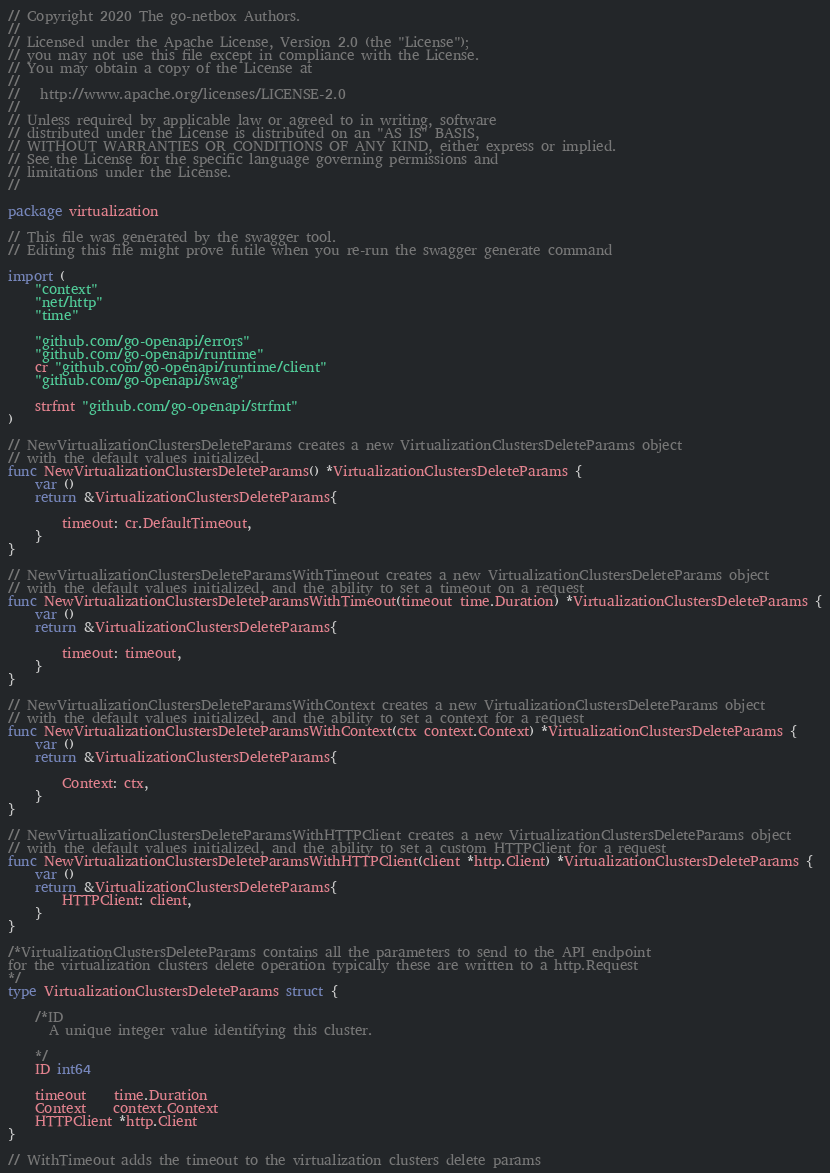Convert code to text. <code><loc_0><loc_0><loc_500><loc_500><_Go_>
// Copyright 2020 The go-netbox Authors.
//
// Licensed under the Apache License, Version 2.0 (the "License");
// you may not use this file except in compliance with the License.
// You may obtain a copy of the License at
//
//   http://www.apache.org/licenses/LICENSE-2.0
//
// Unless required by applicable law or agreed to in writing, software
// distributed under the License is distributed on an "AS IS" BASIS,
// WITHOUT WARRANTIES OR CONDITIONS OF ANY KIND, either express or implied.
// See the License for the specific language governing permissions and
// limitations under the License.
//

package virtualization

// This file was generated by the swagger tool.
// Editing this file might prove futile when you re-run the swagger generate command

import (
	"context"
	"net/http"
	"time"

	"github.com/go-openapi/errors"
	"github.com/go-openapi/runtime"
	cr "github.com/go-openapi/runtime/client"
	"github.com/go-openapi/swag"

	strfmt "github.com/go-openapi/strfmt"
)

// NewVirtualizationClustersDeleteParams creates a new VirtualizationClustersDeleteParams object
// with the default values initialized.
func NewVirtualizationClustersDeleteParams() *VirtualizationClustersDeleteParams {
	var ()
	return &VirtualizationClustersDeleteParams{

		timeout: cr.DefaultTimeout,
	}
}

// NewVirtualizationClustersDeleteParamsWithTimeout creates a new VirtualizationClustersDeleteParams object
// with the default values initialized, and the ability to set a timeout on a request
func NewVirtualizationClustersDeleteParamsWithTimeout(timeout time.Duration) *VirtualizationClustersDeleteParams {
	var ()
	return &VirtualizationClustersDeleteParams{

		timeout: timeout,
	}
}

// NewVirtualizationClustersDeleteParamsWithContext creates a new VirtualizationClustersDeleteParams object
// with the default values initialized, and the ability to set a context for a request
func NewVirtualizationClustersDeleteParamsWithContext(ctx context.Context) *VirtualizationClustersDeleteParams {
	var ()
	return &VirtualizationClustersDeleteParams{

		Context: ctx,
	}
}

// NewVirtualizationClustersDeleteParamsWithHTTPClient creates a new VirtualizationClustersDeleteParams object
// with the default values initialized, and the ability to set a custom HTTPClient for a request
func NewVirtualizationClustersDeleteParamsWithHTTPClient(client *http.Client) *VirtualizationClustersDeleteParams {
	var ()
	return &VirtualizationClustersDeleteParams{
		HTTPClient: client,
	}
}

/*VirtualizationClustersDeleteParams contains all the parameters to send to the API endpoint
for the virtualization clusters delete operation typically these are written to a http.Request
*/
type VirtualizationClustersDeleteParams struct {

	/*ID
	  A unique integer value identifying this cluster.

	*/
	ID int64

	timeout    time.Duration
	Context    context.Context
	HTTPClient *http.Client
}

// WithTimeout adds the timeout to the virtualization clusters delete params</code> 